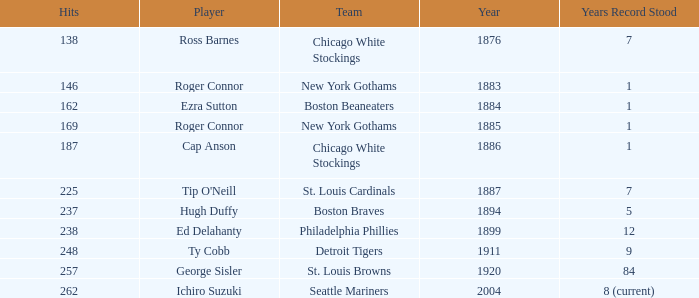After 1885, who was the player with a record of 238 hits? Ed Delahanty. 